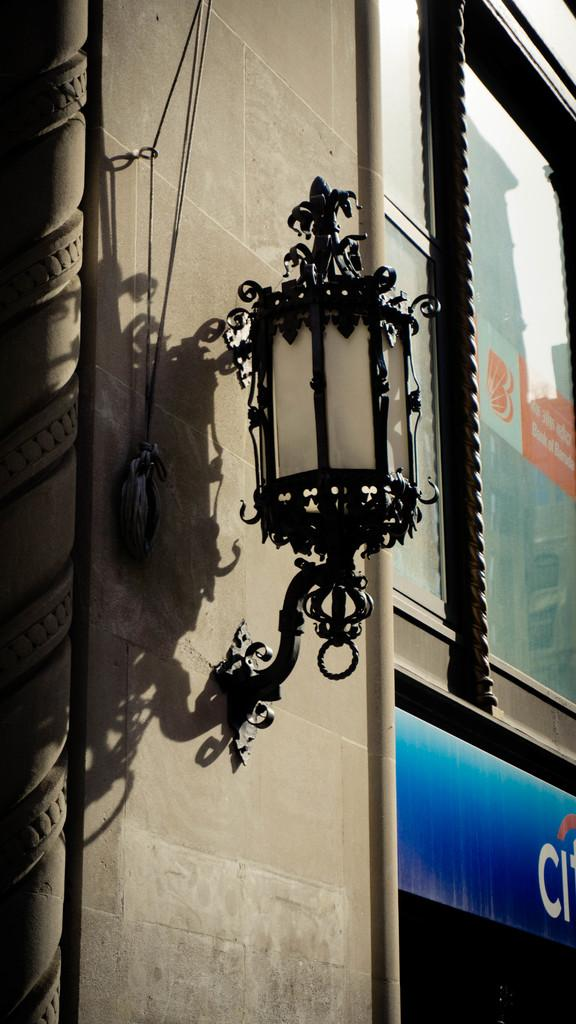What is present on the wall in the image? There is a light on the wall in the image. Can you describe the light on the wall? The light on the wall is a single light fixture. How many cars are parked in front of the wall in the image? There is no mention of cars in the image; the image only features a wall with a light on it. What time of day is it in the image, given the presence of the morning light? The time of day is not specified in the image, and there is no mention of morning light. 